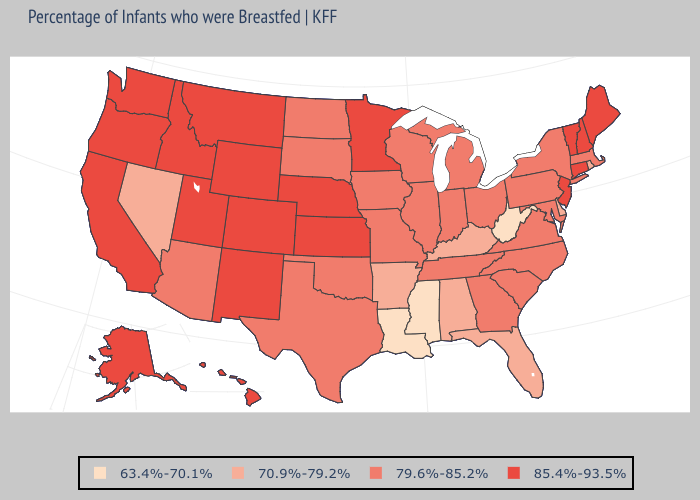Among the states that border Arkansas , does Mississippi have the lowest value?
Answer briefly. Yes. What is the lowest value in states that border Massachusetts?
Concise answer only. 70.9%-79.2%. Which states hav the highest value in the MidWest?
Short answer required. Kansas, Minnesota, Nebraska. Name the states that have a value in the range 63.4%-70.1%?
Give a very brief answer. Louisiana, Mississippi, West Virginia. Name the states that have a value in the range 79.6%-85.2%?
Answer briefly. Arizona, Georgia, Illinois, Indiana, Iowa, Maryland, Massachusetts, Michigan, Missouri, New York, North Carolina, North Dakota, Ohio, Oklahoma, Pennsylvania, South Carolina, South Dakota, Tennessee, Texas, Virginia, Wisconsin. What is the value of Wyoming?
Give a very brief answer. 85.4%-93.5%. Name the states that have a value in the range 70.9%-79.2%?
Keep it brief. Alabama, Arkansas, Delaware, Florida, Kentucky, Nevada, Rhode Island. What is the value of Minnesota?
Short answer required. 85.4%-93.5%. What is the value of Arkansas?
Concise answer only. 70.9%-79.2%. Name the states that have a value in the range 70.9%-79.2%?
Keep it brief. Alabama, Arkansas, Delaware, Florida, Kentucky, Nevada, Rhode Island. Does Arkansas have a lower value than Virginia?
Short answer required. Yes. Among the states that border Texas , which have the highest value?
Answer briefly. New Mexico. What is the value of Maryland?
Be succinct. 79.6%-85.2%. Name the states that have a value in the range 79.6%-85.2%?
Give a very brief answer. Arizona, Georgia, Illinois, Indiana, Iowa, Maryland, Massachusetts, Michigan, Missouri, New York, North Carolina, North Dakota, Ohio, Oklahoma, Pennsylvania, South Carolina, South Dakota, Tennessee, Texas, Virginia, Wisconsin. What is the value of Missouri?
Be succinct. 79.6%-85.2%. 